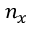<formula> <loc_0><loc_0><loc_500><loc_500>n _ { x }</formula> 